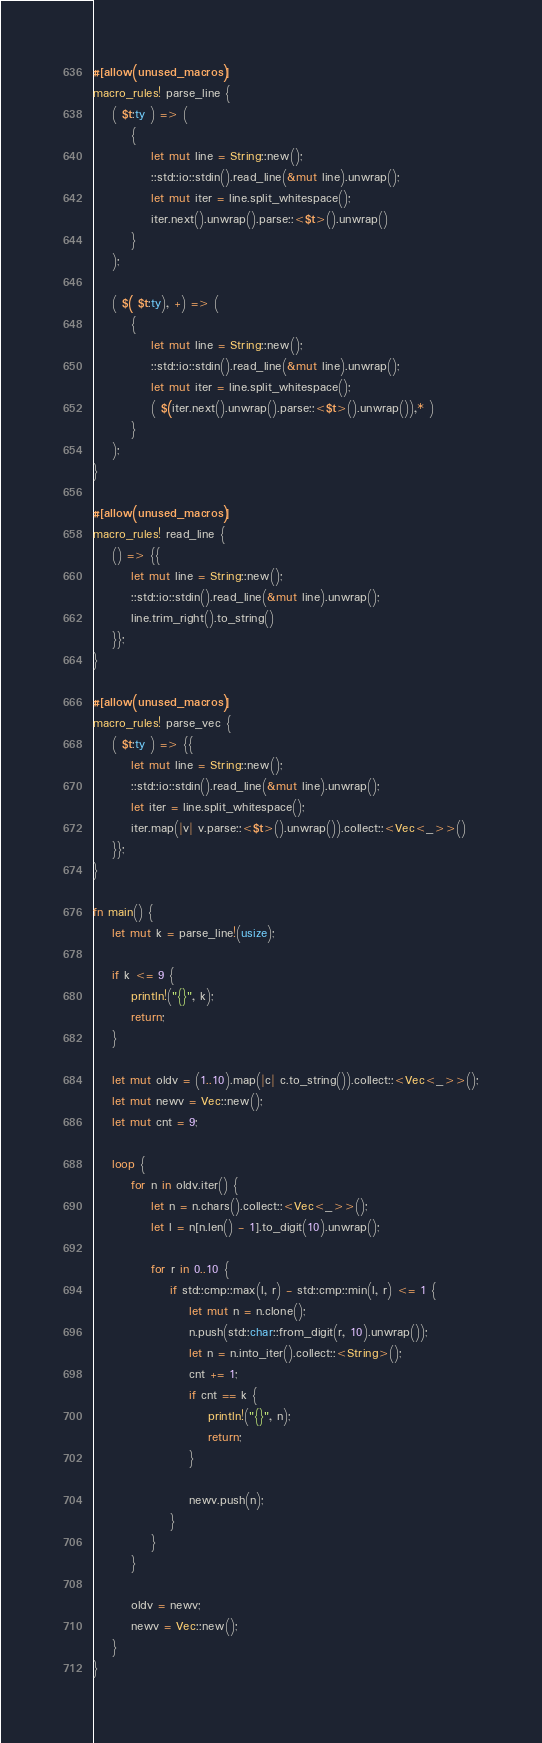<code> <loc_0><loc_0><loc_500><loc_500><_Rust_>#[allow(unused_macros)]
macro_rules! parse_line {
    ( $t:ty ) => (
        {
            let mut line = String::new();
            ::std::io::stdin().read_line(&mut line).unwrap();
            let mut iter = line.split_whitespace();
            iter.next().unwrap().parse::<$t>().unwrap()
        }
    );

    ( $( $t:ty), +) => (
        {
            let mut line = String::new();
            ::std::io::stdin().read_line(&mut line).unwrap();
            let mut iter = line.split_whitespace();
            ( $(iter.next().unwrap().parse::<$t>().unwrap()),* )
        }
    );
}

#[allow(unused_macros)]
macro_rules! read_line {
    () => {{
        let mut line = String::new();
        ::std::io::stdin().read_line(&mut line).unwrap();
        line.trim_right().to_string()
    }};
}

#[allow(unused_macros)]
macro_rules! parse_vec {
    ( $t:ty ) => {{
        let mut line = String::new();
        ::std::io::stdin().read_line(&mut line).unwrap();
        let iter = line.split_whitespace();
        iter.map(|v| v.parse::<$t>().unwrap()).collect::<Vec<_>>()
    }};
}

fn main() {
    let mut k = parse_line!(usize);

    if k <= 9 {
        println!("{}", k);
        return;
    }

    let mut oldv = (1..10).map(|c| c.to_string()).collect::<Vec<_>>();
    let mut newv = Vec::new();
    let mut cnt = 9;

    loop {
        for n in oldv.iter() {
            let n = n.chars().collect::<Vec<_>>();
            let l = n[n.len() - 1].to_digit(10).unwrap();

            for r in 0..10 {
                if std::cmp::max(l, r) - std::cmp::min(l, r) <= 1 {
                    let mut n = n.clone();
                    n.push(std::char::from_digit(r, 10).unwrap());
                    let n = n.into_iter().collect::<String>();
                    cnt += 1;
                    if cnt == k {
                        println!("{}", n);
                        return;
                    }

                    newv.push(n);
                }
            }
        }

        oldv = newv;
        newv = Vec::new();
    }
}
</code> 